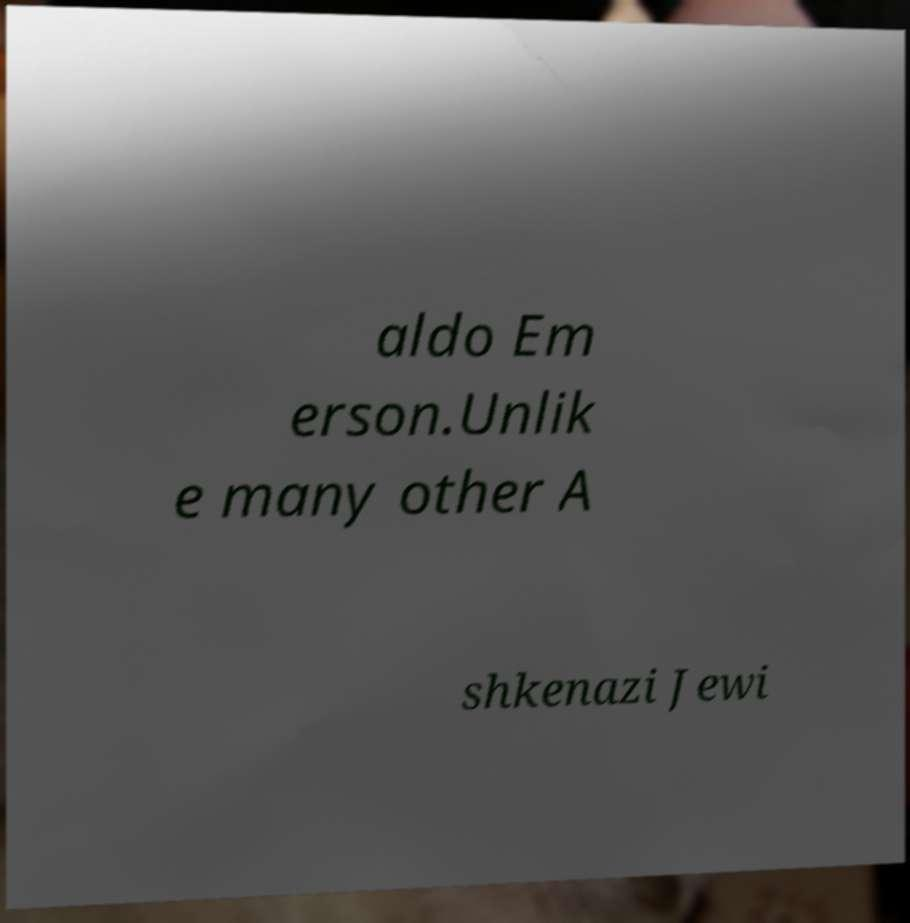I need the written content from this picture converted into text. Can you do that? aldo Em erson.Unlik e many other A shkenazi Jewi 